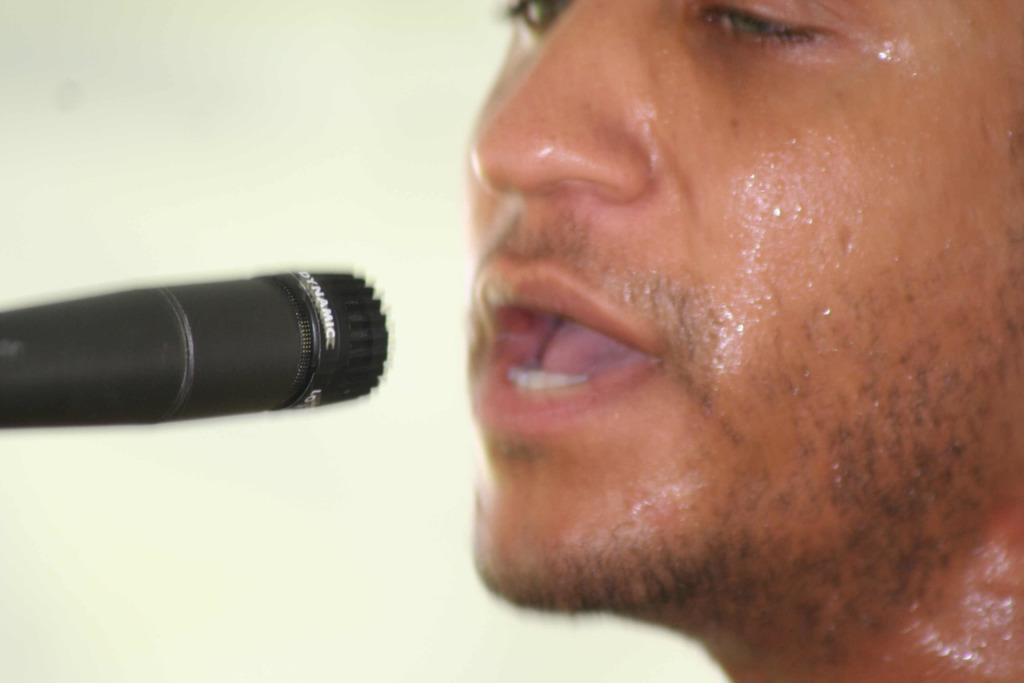What is the main subject of the image? There is a person in the image. What is the person doing in the image? The person is singing. What tool is the person using while singing? The person is using a microphone. What can be seen in the background of the image? There is a wall in the background of the image. Where is the park located in the image? There is no park present in the image. What type of team is the person a part of in the image? The image does not provide any information about the person being a part of a team. 